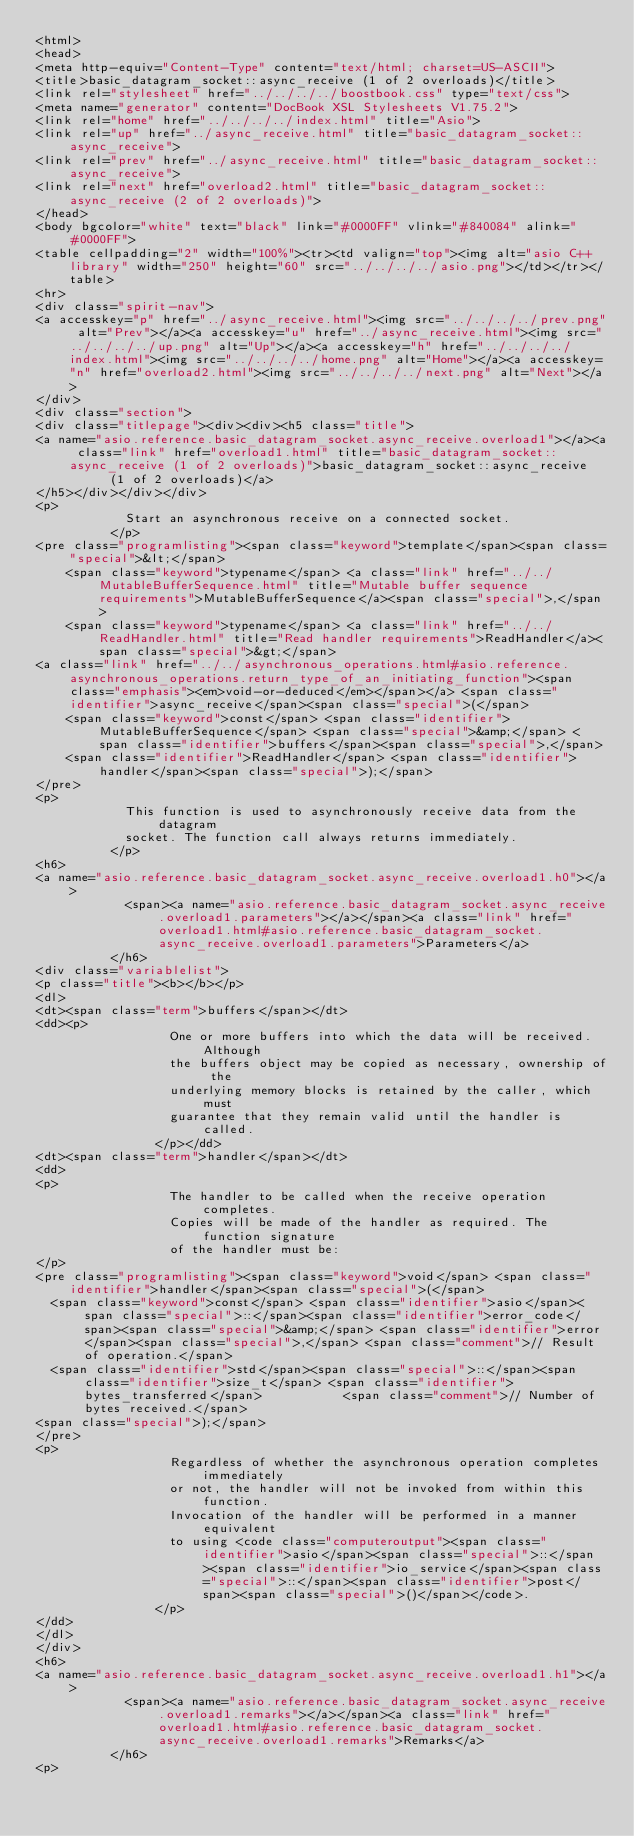<code> <loc_0><loc_0><loc_500><loc_500><_HTML_><html>
<head>
<meta http-equiv="Content-Type" content="text/html; charset=US-ASCII">
<title>basic_datagram_socket::async_receive (1 of 2 overloads)</title>
<link rel="stylesheet" href="../../../../boostbook.css" type="text/css">
<meta name="generator" content="DocBook XSL Stylesheets V1.75.2">
<link rel="home" href="../../../../index.html" title="Asio">
<link rel="up" href="../async_receive.html" title="basic_datagram_socket::async_receive">
<link rel="prev" href="../async_receive.html" title="basic_datagram_socket::async_receive">
<link rel="next" href="overload2.html" title="basic_datagram_socket::async_receive (2 of 2 overloads)">
</head>
<body bgcolor="white" text="black" link="#0000FF" vlink="#840084" alink="#0000FF">
<table cellpadding="2" width="100%"><tr><td valign="top"><img alt="asio C++ library" width="250" height="60" src="../../../../asio.png"></td></tr></table>
<hr>
<div class="spirit-nav">
<a accesskey="p" href="../async_receive.html"><img src="../../../../prev.png" alt="Prev"></a><a accesskey="u" href="../async_receive.html"><img src="../../../../up.png" alt="Up"></a><a accesskey="h" href="../../../../index.html"><img src="../../../../home.png" alt="Home"></a><a accesskey="n" href="overload2.html"><img src="../../../../next.png" alt="Next"></a>
</div>
<div class="section">
<div class="titlepage"><div><div><h5 class="title">
<a name="asio.reference.basic_datagram_socket.async_receive.overload1"></a><a class="link" href="overload1.html" title="basic_datagram_socket::async_receive (1 of 2 overloads)">basic_datagram_socket::async_receive
          (1 of 2 overloads)</a>
</h5></div></div></div>
<p>
            Start an asynchronous receive on a connected socket.
          </p>
<pre class="programlisting"><span class="keyword">template</span><span class="special">&lt;</span>
    <span class="keyword">typename</span> <a class="link" href="../../MutableBufferSequence.html" title="Mutable buffer sequence requirements">MutableBufferSequence</a><span class="special">,</span>
    <span class="keyword">typename</span> <a class="link" href="../../ReadHandler.html" title="Read handler requirements">ReadHandler</a><span class="special">&gt;</span>
<a class="link" href="../../asynchronous_operations.html#asio.reference.asynchronous_operations.return_type_of_an_initiating_function"><span class="emphasis"><em>void-or-deduced</em></span></a> <span class="identifier">async_receive</span><span class="special">(</span>
    <span class="keyword">const</span> <span class="identifier">MutableBufferSequence</span> <span class="special">&amp;</span> <span class="identifier">buffers</span><span class="special">,</span>
    <span class="identifier">ReadHandler</span> <span class="identifier">handler</span><span class="special">);</span>
</pre>
<p>
            This function is used to asynchronously receive data from the datagram
            socket. The function call always returns immediately.
          </p>
<h6>
<a name="asio.reference.basic_datagram_socket.async_receive.overload1.h0"></a>
            <span><a name="asio.reference.basic_datagram_socket.async_receive.overload1.parameters"></a></span><a class="link" href="overload1.html#asio.reference.basic_datagram_socket.async_receive.overload1.parameters">Parameters</a>
          </h6>
<div class="variablelist">
<p class="title"><b></b></p>
<dl>
<dt><span class="term">buffers</span></dt>
<dd><p>
                  One or more buffers into which the data will be received. Although
                  the buffers object may be copied as necessary, ownership of the
                  underlying memory blocks is retained by the caller, which must
                  guarantee that they remain valid until the handler is called.
                </p></dd>
<dt><span class="term">handler</span></dt>
<dd>
<p>
                  The handler to be called when the receive operation completes.
                  Copies will be made of the handler as required. The function signature
                  of the handler must be:
</p>
<pre class="programlisting"><span class="keyword">void</span> <span class="identifier">handler</span><span class="special">(</span>
  <span class="keyword">const</span> <span class="identifier">asio</span><span class="special">::</span><span class="identifier">error_code</span><span class="special">&amp;</span> <span class="identifier">error</span><span class="special">,</span> <span class="comment">// Result of operation.</span>
  <span class="identifier">std</span><span class="special">::</span><span class="identifier">size_t</span> <span class="identifier">bytes_transferred</span>           <span class="comment">// Number of bytes received.</span>
<span class="special">);</span>
</pre>
<p>
                  Regardless of whether the asynchronous operation completes immediately
                  or not, the handler will not be invoked from within this function.
                  Invocation of the handler will be performed in a manner equivalent
                  to using <code class="computeroutput"><span class="identifier">asio</span><span class="special">::</span><span class="identifier">io_service</span><span class="special">::</span><span class="identifier">post</span><span class="special">()</span></code>.
                </p>
</dd>
</dl>
</div>
<h6>
<a name="asio.reference.basic_datagram_socket.async_receive.overload1.h1"></a>
            <span><a name="asio.reference.basic_datagram_socket.async_receive.overload1.remarks"></a></span><a class="link" href="overload1.html#asio.reference.basic_datagram_socket.async_receive.overload1.remarks">Remarks</a>
          </h6>
<p></code> 